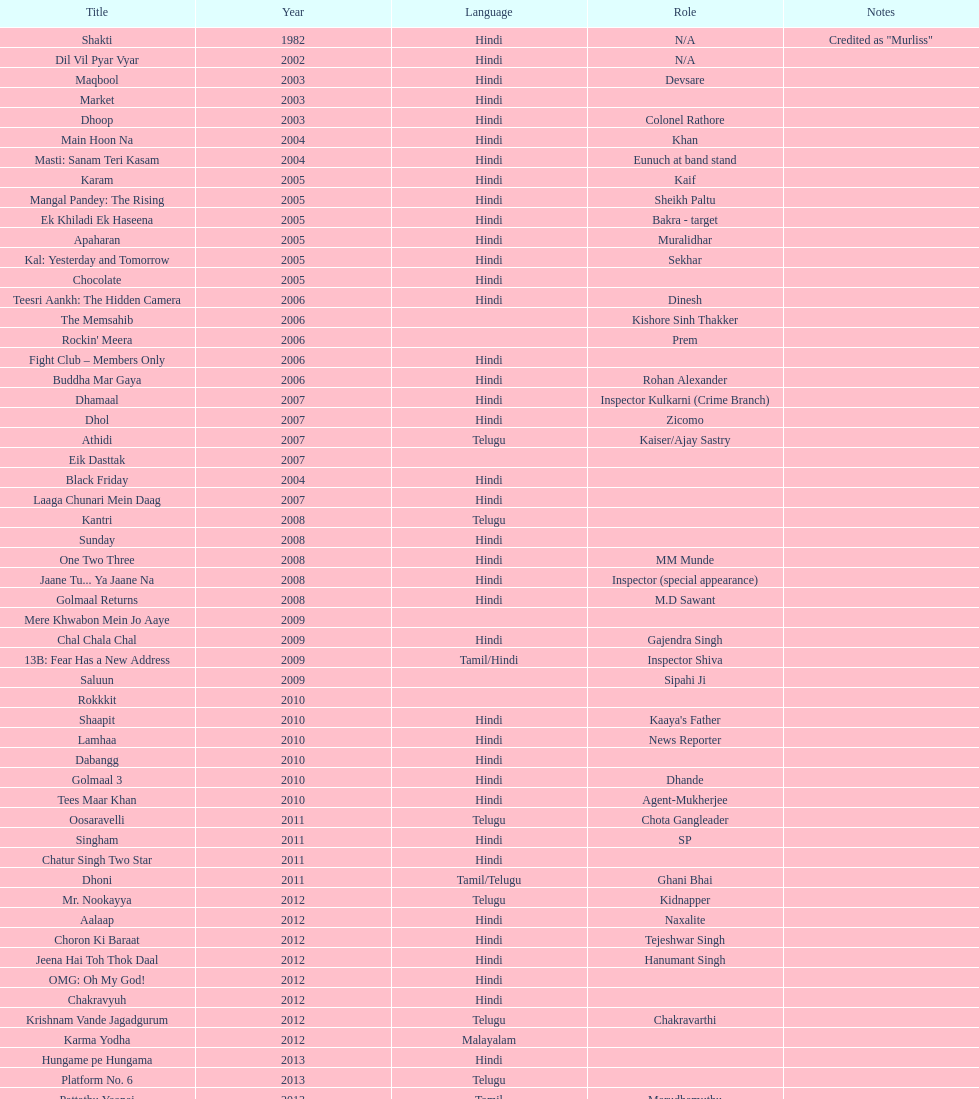What is the first language after hindi Telugu. Give me the full table as a dictionary. {'header': ['Title', 'Year', 'Language', 'Role', 'Notes'], 'rows': [['Shakti', '1982', 'Hindi', 'N/A', 'Credited as "Murliss"'], ['Dil Vil Pyar Vyar', '2002', 'Hindi', 'N/A', ''], ['Maqbool', '2003', 'Hindi', 'Devsare', ''], ['Market', '2003', 'Hindi', '', ''], ['Dhoop', '2003', 'Hindi', 'Colonel Rathore', ''], ['Main Hoon Na', '2004', 'Hindi', 'Khan', ''], ['Masti: Sanam Teri Kasam', '2004', 'Hindi', 'Eunuch at band stand', ''], ['Karam', '2005', 'Hindi', 'Kaif', ''], ['Mangal Pandey: The Rising', '2005', 'Hindi', 'Sheikh Paltu', ''], ['Ek Khiladi Ek Haseena', '2005', 'Hindi', 'Bakra - target', ''], ['Apaharan', '2005', 'Hindi', 'Muralidhar', ''], ['Kal: Yesterday and Tomorrow', '2005', 'Hindi', 'Sekhar', ''], ['Chocolate', '2005', 'Hindi', '', ''], ['Teesri Aankh: The Hidden Camera', '2006', 'Hindi', 'Dinesh', ''], ['The Memsahib', '2006', '', 'Kishore Sinh Thakker', ''], ["Rockin' Meera", '2006', '', 'Prem', ''], ['Fight Club – Members Only', '2006', 'Hindi', '', ''], ['Buddha Mar Gaya', '2006', 'Hindi', 'Rohan Alexander', ''], ['Dhamaal', '2007', 'Hindi', 'Inspector Kulkarni (Crime Branch)', ''], ['Dhol', '2007', 'Hindi', 'Zicomo', ''], ['Athidi', '2007', 'Telugu', 'Kaiser/Ajay Sastry', ''], ['Eik Dasttak', '2007', '', '', ''], ['Black Friday', '2004', 'Hindi', '', ''], ['Laaga Chunari Mein Daag', '2007', 'Hindi', '', ''], ['Kantri', '2008', 'Telugu', '', ''], ['Sunday', '2008', 'Hindi', '', ''], ['One Two Three', '2008', 'Hindi', 'MM Munde', ''], ['Jaane Tu... Ya Jaane Na', '2008', 'Hindi', 'Inspector (special appearance)', ''], ['Golmaal Returns', '2008', 'Hindi', 'M.D Sawant', ''], ['Mere Khwabon Mein Jo Aaye', '2009', '', '', ''], ['Chal Chala Chal', '2009', 'Hindi', 'Gajendra Singh', ''], ['13B: Fear Has a New Address', '2009', 'Tamil/Hindi', 'Inspector Shiva', ''], ['Saluun', '2009', '', 'Sipahi Ji', ''], ['Rokkkit', '2010', '', '', ''], ['Shaapit', '2010', 'Hindi', "Kaaya's Father", ''], ['Lamhaa', '2010', 'Hindi', 'News Reporter', ''], ['Dabangg', '2010', 'Hindi', '', ''], ['Golmaal 3', '2010', 'Hindi', 'Dhande', ''], ['Tees Maar Khan', '2010', 'Hindi', 'Agent-Mukherjee', ''], ['Oosaravelli', '2011', 'Telugu', 'Chota Gangleader', ''], ['Singham', '2011', 'Hindi', 'SP', ''], ['Chatur Singh Two Star', '2011', 'Hindi', '', ''], ['Dhoni', '2011', 'Tamil/Telugu', 'Ghani Bhai', ''], ['Mr. Nookayya', '2012', 'Telugu', 'Kidnapper', ''], ['Aalaap', '2012', 'Hindi', 'Naxalite', ''], ['Choron Ki Baraat', '2012', 'Hindi', 'Tejeshwar Singh', ''], ['Jeena Hai Toh Thok Daal', '2012', 'Hindi', 'Hanumant Singh', ''], ['OMG: Oh My God!', '2012', 'Hindi', '', ''], ['Chakravyuh', '2012', 'Hindi', '', ''], ['Krishnam Vande Jagadgurum', '2012', 'Telugu', 'Chakravarthi', ''], ['Karma Yodha', '2012', 'Malayalam', '', ''], ['Hungame pe Hungama', '2013', 'Hindi', '', ''], ['Platform No. 6', '2013', 'Telugu', '', ''], ['Pattathu Yaanai', '2013', 'Tamil', 'Marudhamuthu', ''], ['Zindagi 50-50', '2013', 'Hindi', '', ''], ['Yevadu', '2013', 'Telugu', 'Durani', ''], ['Karmachari', '2013', 'Telugu', '', '']]} 